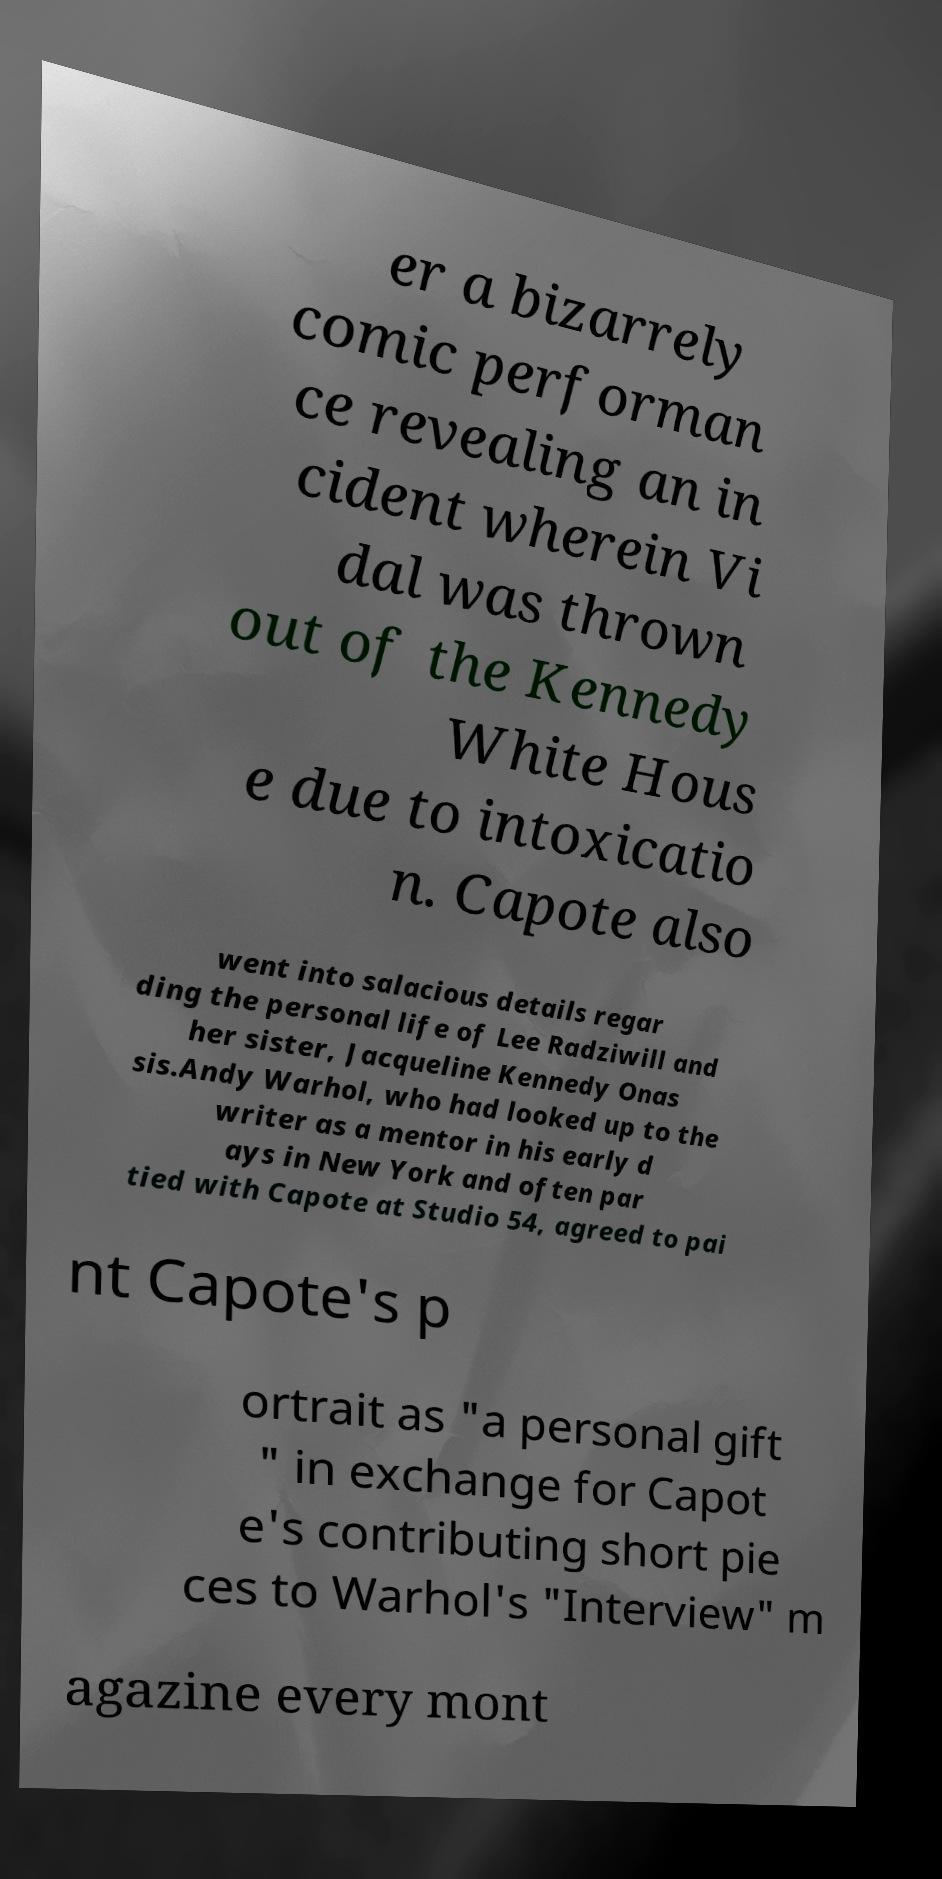What messages or text are displayed in this image? I need them in a readable, typed format. er a bizarrely comic performan ce revealing an in cident wherein Vi dal was thrown out of the Kennedy White Hous e due to intoxicatio n. Capote also went into salacious details regar ding the personal life of Lee Radziwill and her sister, Jacqueline Kennedy Onas sis.Andy Warhol, who had looked up to the writer as a mentor in his early d ays in New York and often par tied with Capote at Studio 54, agreed to pai nt Capote's p ortrait as "a personal gift " in exchange for Capot e's contributing short pie ces to Warhol's "Interview" m agazine every mont 